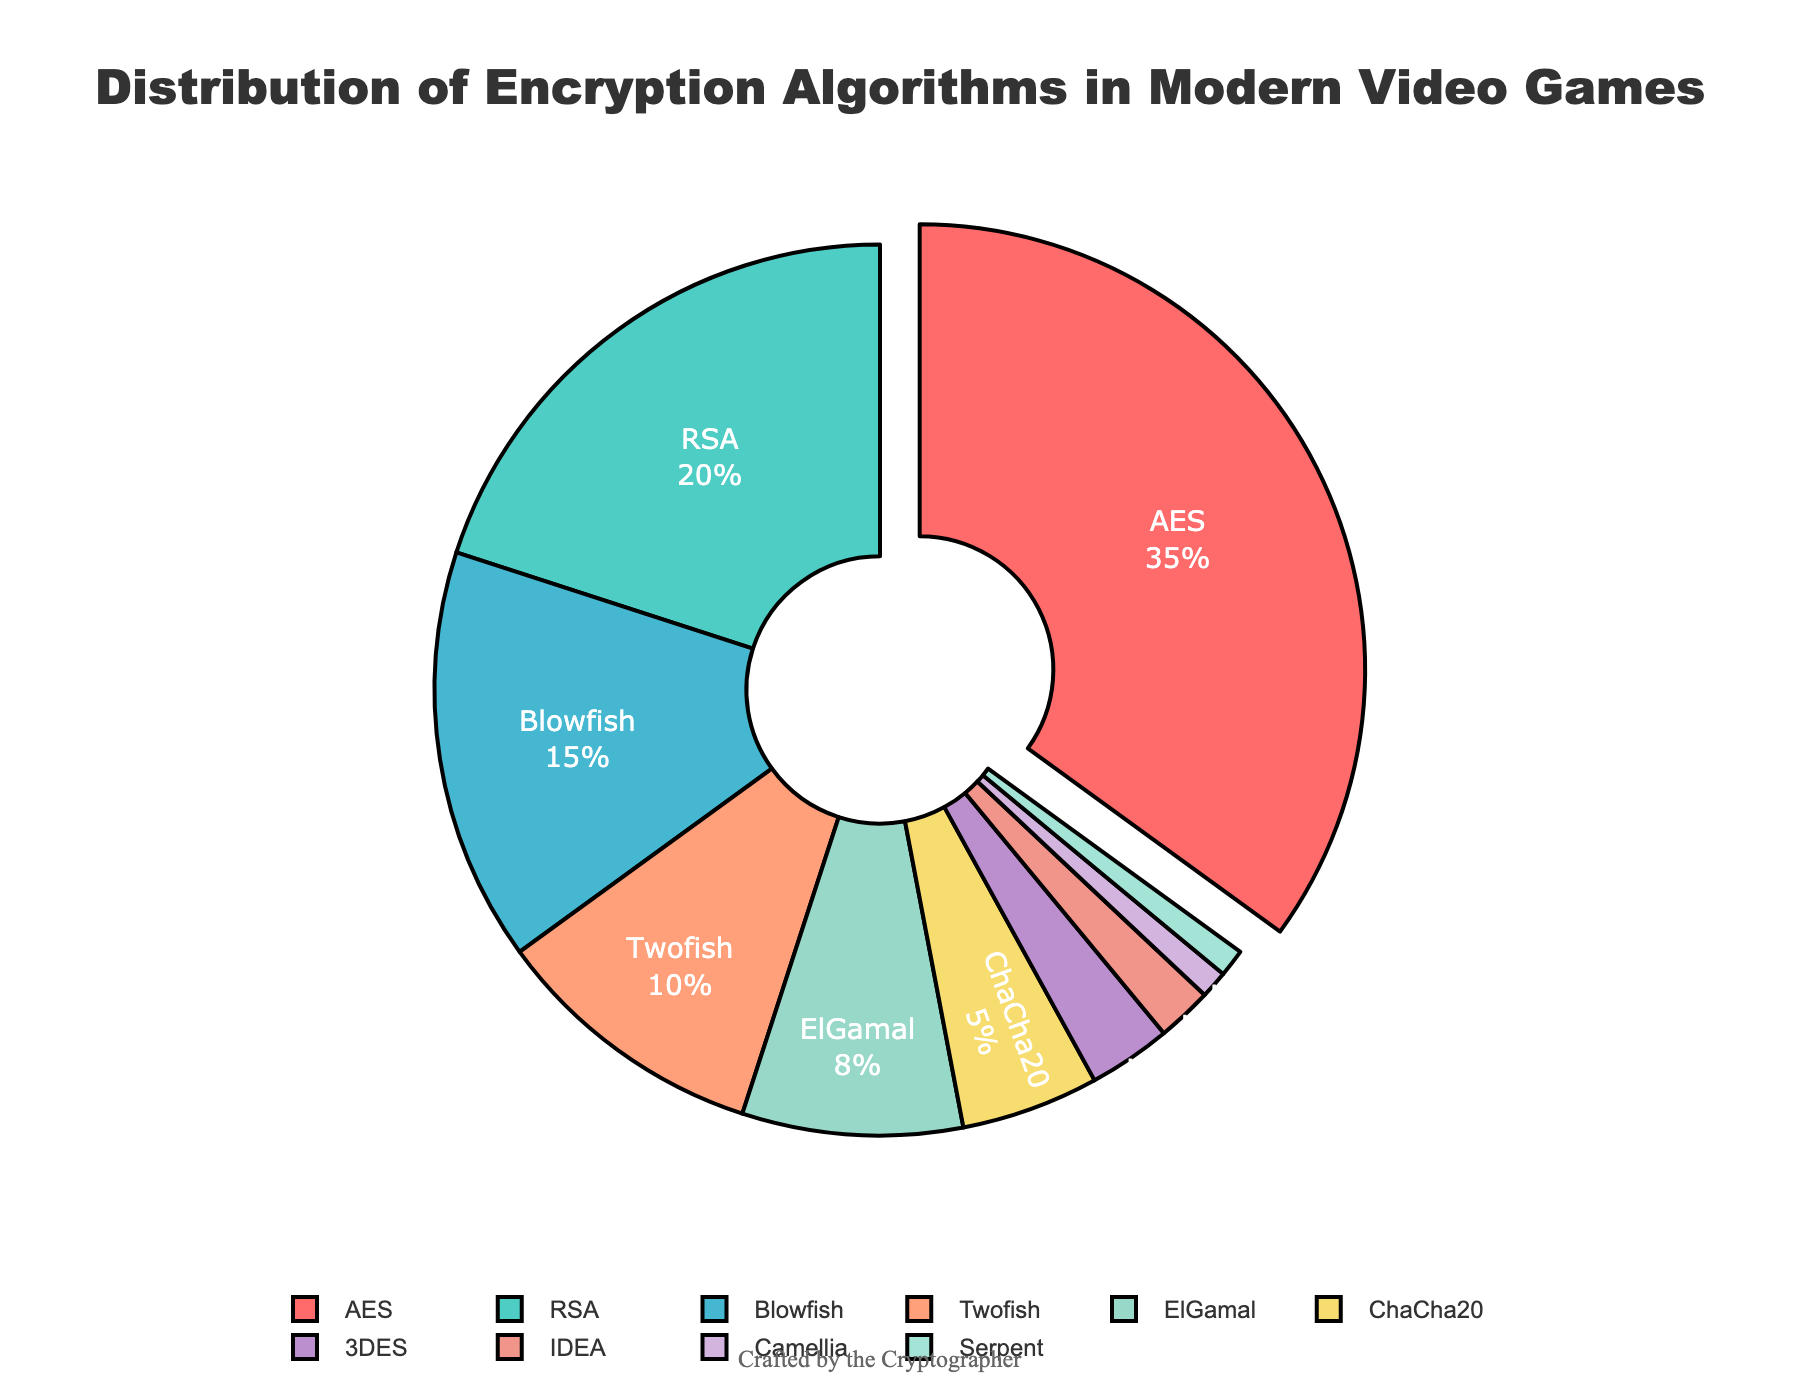Which encryption algorithm is the most commonly used? The most commonly used encryption algorithm is the one with the highest percentage in the chart. The AES section is highlighted and labeled as having 35%.
Answer: AES Which two algorithms have the smallest usage percentages and what are they? To find the two algorithms with the smallest usage, look for the two sections with the smallest percentages. IDEA and Serpent both show 1% usage.
Answer: IDEA, Serpent How much more is the percentage of Blowfish usage than Twofish? The percentage of Blowfish is 15%, and the percentage of Twofish is 10%. Subtract Twofish's percentage from Blowfish's to find the difference: 15% - 10%.
Answer: 5% What percentage of the chart do all algorithms combined other than AES and RSA represent? Subtract the combined percentage of AES (35%) and RSA (20%) from 100%. First, sum 35% and 20%, and then subtract from 100%: 100% - (35% + 20%) = 100% - 55%.
Answer: 45% Which algorithm is represented by the red color in the chart? Identify the algorithm associated with the red section by finding the label connected to the red color. AES is represented by red.
Answer: AES Is the combined usage of ElGamal and ChaCha20 greater than the usage of Blowfish? First, add the percentages of ElGamal (8%) and ChaCha20 (5%). Then compare the sum to the percentage of Blowfish (15%): 8% + 5% = 13%, which is less than 15%.
Answer: No How many algorithms have a usage percentage of 10% or higher? Count the sections in the chart with percentages equal to or greater than 10%. AES (35%), RSA (20%), Blowfish (15%), and Twofish (10%) meet this criteria, totaling four.
Answer: 4 Which encryption algorithm usage combined with Serpent equals exactly 3%? To find which algorithm, when added to Serpent (1%), equals 3%, look for an algorithm with 2%. IDEA is the algorithm with 2%.
Answer: IDEA What is the average percentage of usage for the algorithms with less than 5% usage? Add the percentages of ChaCha20 (5%), 3DES (3%), IDEA (2%), Camellia (1%), and Serpent (1%). Calculate the average by dividing their sum by the number of these algorithms: (5 + 3 + 2 + 1 + 1) / 5 = 12 / 5.
Answer: 2.4% Which segment of the chart is yellow? Identify the part of the pie chart that is shaded in yellow by finding the corresponding label. The yellow section represents ChaCha20.
Answer: ChaCha20 